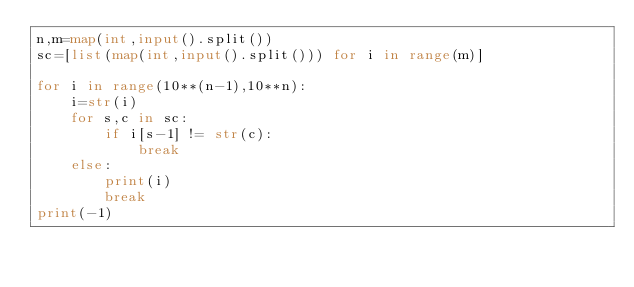<code> <loc_0><loc_0><loc_500><loc_500><_Python_>n,m=map(int,input().split())
sc=[list(map(int,input().split())) for i in range(m)]

for i in range(10**(n-1),10**n):
    i=str(i)
    for s,c in sc:
        if i[s-1] != str(c):
            break
    else:
        print(i)
        break
print(-1)</code> 